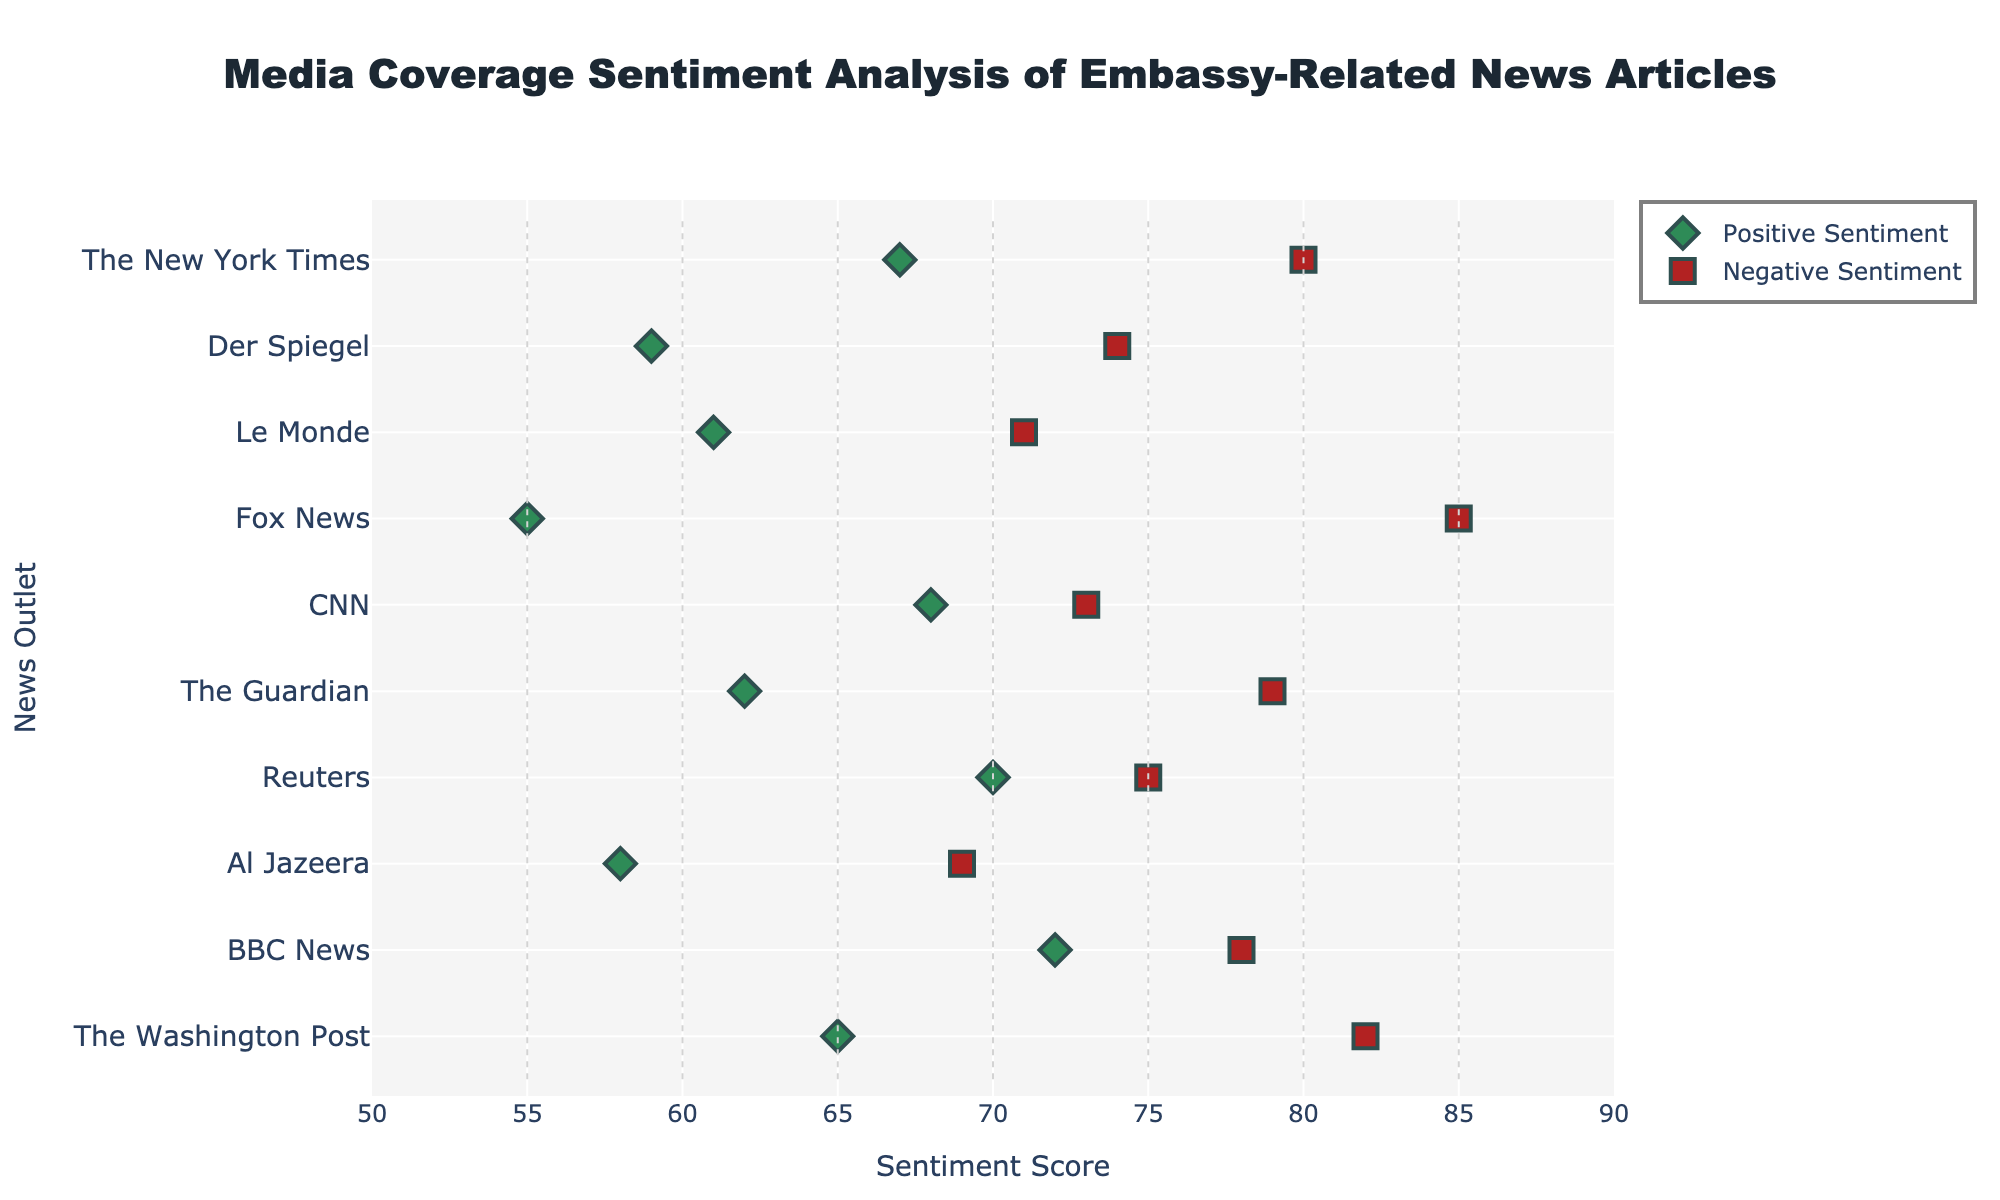what is the title of the figure? The title can be found at the top of the figure. It is written in bold and uses a larger font size for emphasis.
Answer: Media Coverage Sentiment Analysis of Embassy-Related News Articles How many news outlets are listed? Count the number of different news outlets shown on the y-axis of the figure.
Answer: 10 Which news outlet has the highest positive sentiment score? Identify the dot representing positive sentiment for each news outlet and find the one with the highest score along the x-axis.
Answer: BBC News What is the range of negative sentiment scores for The Washington Post? Look at the negative sentiment score for The Washington Post on the figure. It can be found along the y-axis where The Washington Post is labeled.
Answer: 82 Which news outlet has a wider range between positive and negative sentiment scores, Fox News or The Guardian? Compare the difference between positive and negative sentiment scores for both news outlets: Fox News (85 - 55 = 30) and The Guardian (79 - 62 = 17).
Answer: Fox News Are there any news outlets where the positive and negative sentiment scores are equal? Check if any news outlet has the same x-axis value for both positive and negative sentiment markers.
Answer: No What is the average positive sentiment score across all news outlets? Sum the positive sentiment scores and then divide by the number of news outlets: (65 + 72 + 58 + 70 + 62 + 68 + 55 + 61 + 59 + 67) / 10.
Answer: 63.7 Which news outlet has the closest positive sentiment score to 60? Identify the positive sentiment scores closest to 60 and find the corresponding news outlet.
Answer: Le Monde Which news outlet has the least negative sentiment score? Identify the dot representing negative sentiment for each news outlet and find the one with the lowest score along the x-axis.
Answer: Al Jazeera What is the difference between the negative sentiment scores of The New York Times and Reuters? Find the negative sentiment scores for The New York Times (80) and Reuters (75) and calculate the difference: 80 - 75.
Answer: 5 